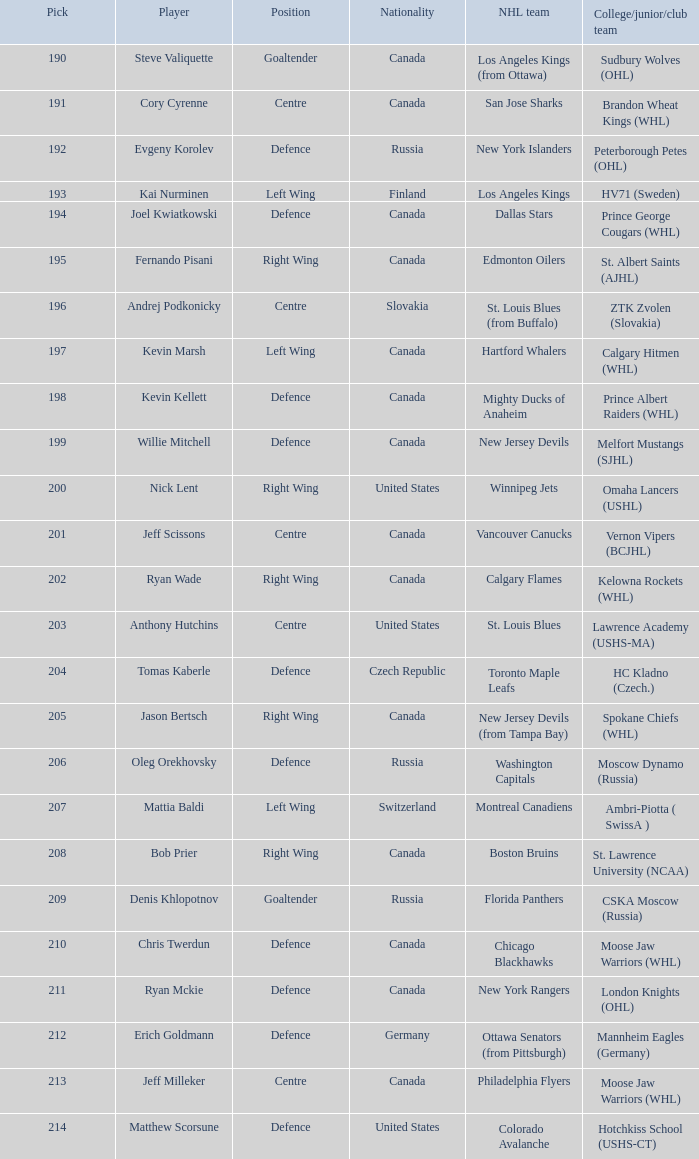Can you mention the option chosen by matthew scorsune? 214.0. 